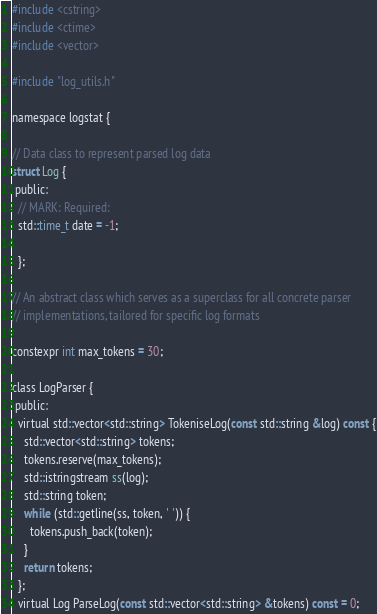<code> <loc_0><loc_0><loc_500><loc_500><_C_>
#include <cstring>
#include <ctime>
#include <vector>

#include "log_utils.h"

namespace logstat {

// Data class to represent parsed log data
struct Log {
 public:
  // MARK: Required:
  std::time_t date = -1;

  };

// An abstract class which serves as a superclass for all concrete parser
// implementations, tailored for specific log formats

constexpr int max_tokens = 30;

class LogParser {
 public:
  virtual std::vector<std::string> TokeniseLog(const std::string &log) const {
    std::vector<std::string> tokens;
    tokens.reserve(max_tokens);
    std::istringstream ss(log);
    std::string token;
    while (std::getline(ss, token, ' ')) {
      tokens.push_back(token);
    }
    return tokens;
  };
  virtual Log ParseLog(const std::vector<std::string> &tokens) const = 0;</code> 